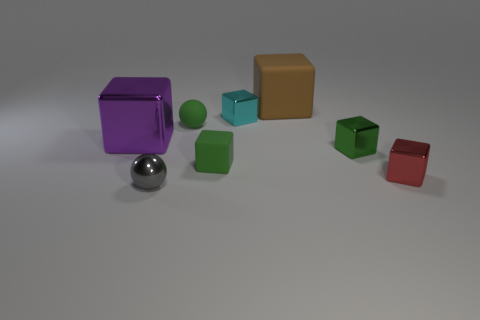What material is the large cube behind the cyan metal block?
Your answer should be very brief. Rubber. There is a tiny metallic object that is the same color as the tiny matte block; what is its shape?
Keep it short and to the point. Cube. Are there any large purple objects made of the same material as the tiny red cube?
Your answer should be very brief. Yes. What is the size of the red metallic thing?
Offer a terse response. Small. What number of cyan things are either tiny rubber cubes or rubber objects?
Keep it short and to the point. 0. What number of tiny red objects have the same shape as the small cyan object?
Keep it short and to the point. 1. How many other rubber cubes have the same size as the red block?
Offer a terse response. 1. There is a green object that is the same shape as the tiny gray shiny thing; what material is it?
Your response must be concise. Rubber. There is a big block behind the rubber ball; what is its color?
Your response must be concise. Brown. Are there more metal blocks that are behind the large purple block than rubber cubes?
Keep it short and to the point. No. 